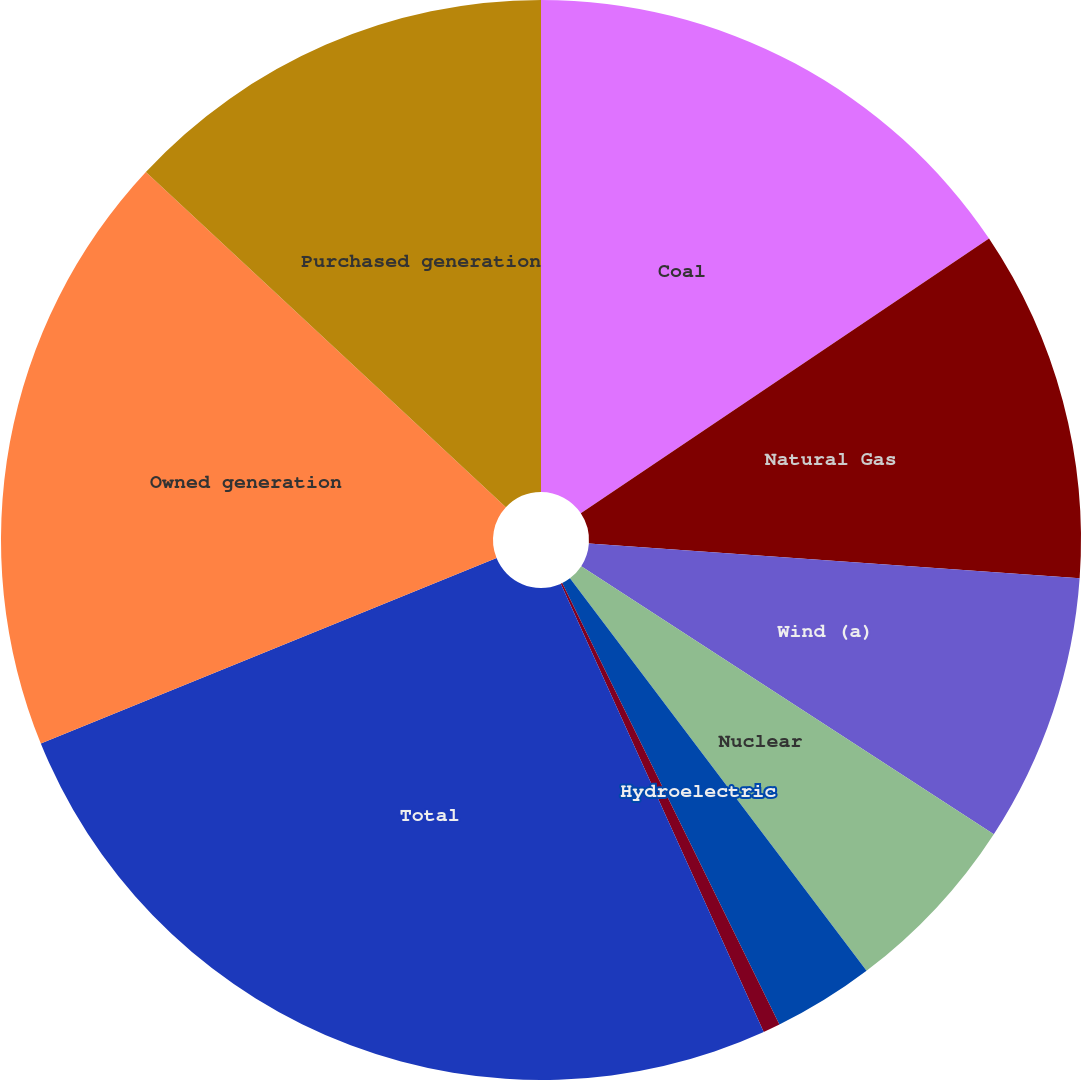Convert chart to OTSL. <chart><loc_0><loc_0><loc_500><loc_500><pie_chart><fcel>Coal<fcel>Natural Gas<fcel>Wind (a)<fcel>Nuclear<fcel>Hydroelectric<fcel>Other (b)<fcel>Total<fcel>Owned generation<fcel>Purchased generation<nl><fcel>15.57%<fcel>10.55%<fcel>8.04%<fcel>5.53%<fcel>3.02%<fcel>0.51%<fcel>25.61%<fcel>18.08%<fcel>13.06%<nl></chart> 